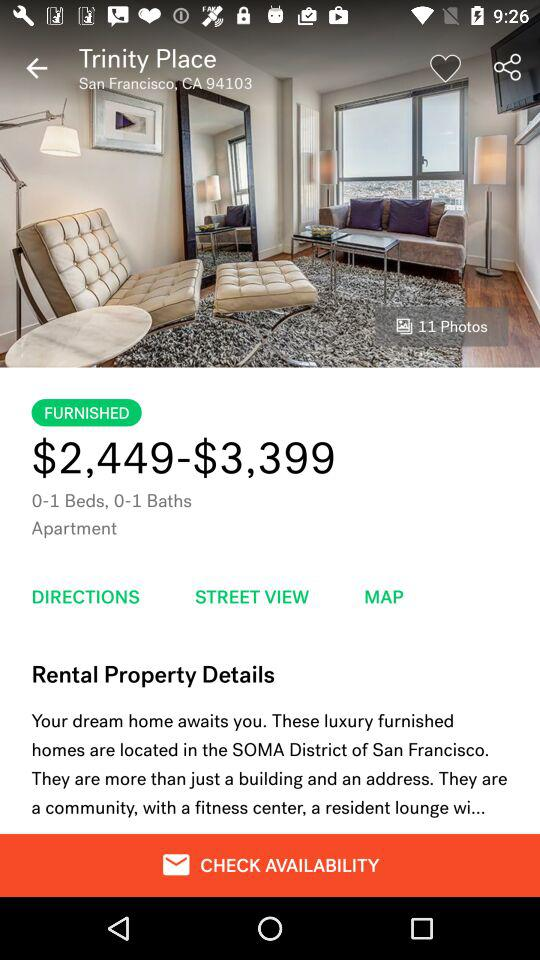Is the apartment furnished or unfurnished? The apartment is furnished. 